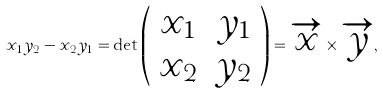Convert formula to latex. <formula><loc_0><loc_0><loc_500><loc_500>x _ { 1 } y _ { 2 } - x _ { 2 } y _ { 1 } = \det \left ( \begin{array} { c c } x _ { 1 } & y _ { 1 } \\ x _ { 2 } & y _ { 2 } \end{array} \right ) = \overrightarrow { x } \times \overrightarrow { y } ,</formula> 